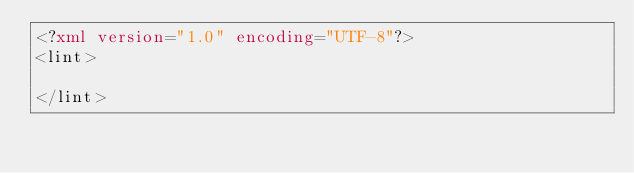<code> <loc_0><loc_0><loc_500><loc_500><_XML_><?xml version="1.0" encoding="UTF-8"?>
<lint>

</lint></code> 